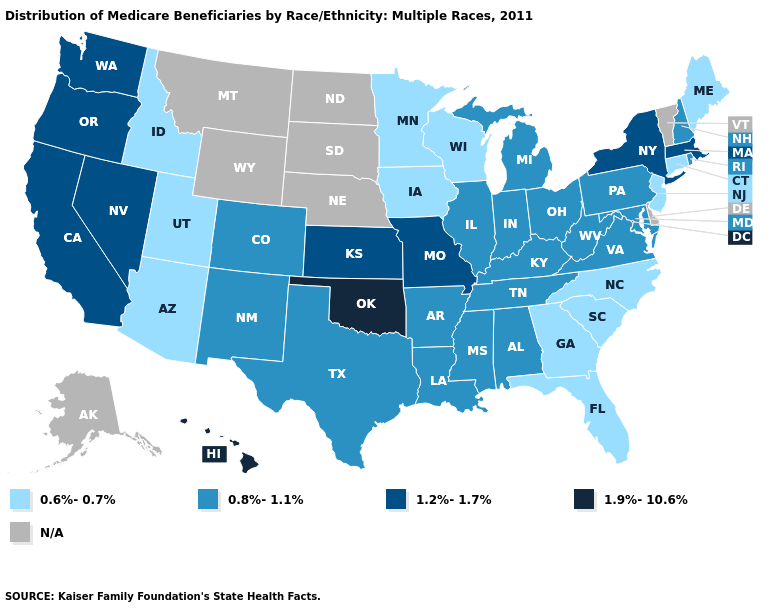Among the states that border Delaware , which have the lowest value?
Write a very short answer. New Jersey. Does Maine have the highest value in the Northeast?
Keep it brief. No. Name the states that have a value in the range 0.8%-1.1%?
Quick response, please. Alabama, Arkansas, Colorado, Illinois, Indiana, Kentucky, Louisiana, Maryland, Michigan, Mississippi, New Hampshire, New Mexico, Ohio, Pennsylvania, Rhode Island, Tennessee, Texas, Virginia, West Virginia. What is the highest value in the Northeast ?
Quick response, please. 1.2%-1.7%. Which states have the lowest value in the USA?
Short answer required. Arizona, Connecticut, Florida, Georgia, Idaho, Iowa, Maine, Minnesota, New Jersey, North Carolina, South Carolina, Utah, Wisconsin. Which states hav the highest value in the MidWest?
Answer briefly. Kansas, Missouri. Name the states that have a value in the range 0.8%-1.1%?
Be succinct. Alabama, Arkansas, Colorado, Illinois, Indiana, Kentucky, Louisiana, Maryland, Michigan, Mississippi, New Hampshire, New Mexico, Ohio, Pennsylvania, Rhode Island, Tennessee, Texas, Virginia, West Virginia. What is the lowest value in states that border South Carolina?
Keep it brief. 0.6%-0.7%. Name the states that have a value in the range 1.9%-10.6%?
Keep it brief. Hawaii, Oklahoma. What is the value of Pennsylvania?
Quick response, please. 0.8%-1.1%. Name the states that have a value in the range 1.2%-1.7%?
Answer briefly. California, Kansas, Massachusetts, Missouri, Nevada, New York, Oregon, Washington. Name the states that have a value in the range 0.6%-0.7%?
Answer briefly. Arizona, Connecticut, Florida, Georgia, Idaho, Iowa, Maine, Minnesota, New Jersey, North Carolina, South Carolina, Utah, Wisconsin. 